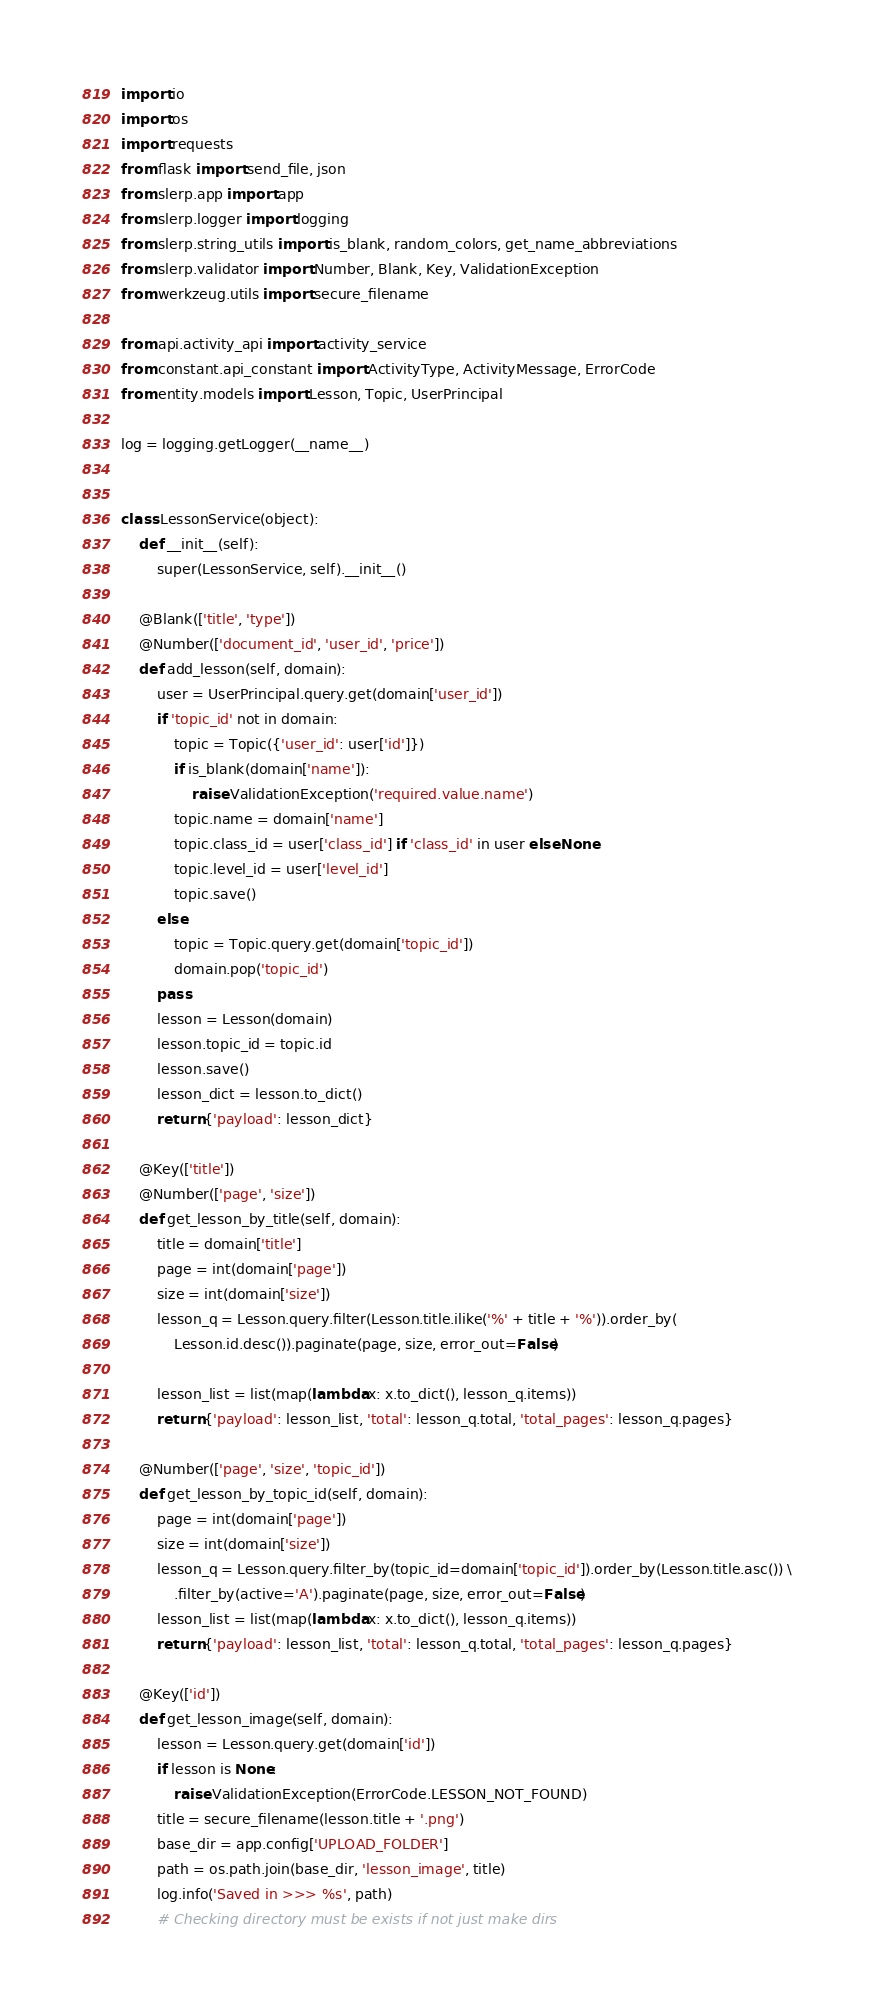Convert code to text. <code><loc_0><loc_0><loc_500><loc_500><_Python_>import io
import os
import requests
from flask import send_file, json
from slerp.app import app
from slerp.logger import logging
from slerp.string_utils import is_blank, random_colors, get_name_abbreviations
from slerp.validator import Number, Blank, Key, ValidationException
from werkzeug.utils import secure_filename

from api.activity_api import activity_service
from constant.api_constant import ActivityType, ActivityMessage, ErrorCode
from entity.models import Lesson, Topic, UserPrincipal

log = logging.getLogger(__name__)


class LessonService(object):
	def __init__(self):
		super(LessonService, self).__init__()
	
	@Blank(['title', 'type'])
	@Number(['document_id', 'user_id', 'price'])
	def add_lesson(self, domain):
		user = UserPrincipal.query.get(domain['user_id'])
		if 'topic_id' not in domain:
			topic = Topic({'user_id': user['id']})
			if is_blank(domain['name']):
				raise ValidationException('required.value.name')
			topic.name = domain['name']
			topic.class_id = user['class_id'] if 'class_id' in user else None
			topic.level_id = user['level_id']
			topic.save()
		else:
			topic = Topic.query.get(domain['topic_id'])
			domain.pop('topic_id')
		pass
		lesson = Lesson(domain)
		lesson.topic_id = topic.id
		lesson.save()
		lesson_dict = lesson.to_dict()
		return {'payload': lesson_dict}
	
	@Key(['title'])
	@Number(['page', 'size'])
	def get_lesson_by_title(self, domain):
		title = domain['title']
		page = int(domain['page'])
		size = int(domain['size'])
		lesson_q = Lesson.query.filter(Lesson.title.ilike('%' + title + '%')).order_by(
			Lesson.id.desc()).paginate(page, size, error_out=False)
		
		lesson_list = list(map(lambda x: x.to_dict(), lesson_q.items))
		return {'payload': lesson_list, 'total': lesson_q.total, 'total_pages': lesson_q.pages}
	
	@Number(['page', 'size', 'topic_id'])
	def get_lesson_by_topic_id(self, domain):
		page = int(domain['page'])
		size = int(domain['size'])
		lesson_q = Lesson.query.filter_by(topic_id=domain['topic_id']).order_by(Lesson.title.asc()) \
			.filter_by(active='A').paginate(page, size, error_out=False)
		lesson_list = list(map(lambda x: x.to_dict(), lesson_q.items))
		return {'payload': lesson_list, 'total': lesson_q.total, 'total_pages': lesson_q.pages}
	
	@Key(['id'])
	def get_lesson_image(self, domain):
		lesson = Lesson.query.get(domain['id'])
		if lesson is None:
			raise ValidationException(ErrorCode.LESSON_NOT_FOUND)
		title = secure_filename(lesson.title + '.png')
		base_dir = app.config['UPLOAD_FOLDER']
		path = os.path.join(base_dir, 'lesson_image', title)
		log.info('Saved in >>> %s', path)
		# Checking directory must be exists if not just make dirs</code> 